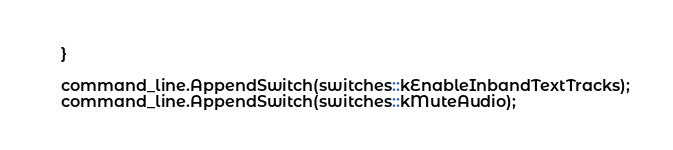Convert code to text. <code><loc_0><loc_0><loc_500><loc_500><_C++_>    }

    command_line.AppendSwitch(switches::kEnableInbandTextTracks);
    command_line.AppendSwitch(switches::kMuteAudio);
</code> 